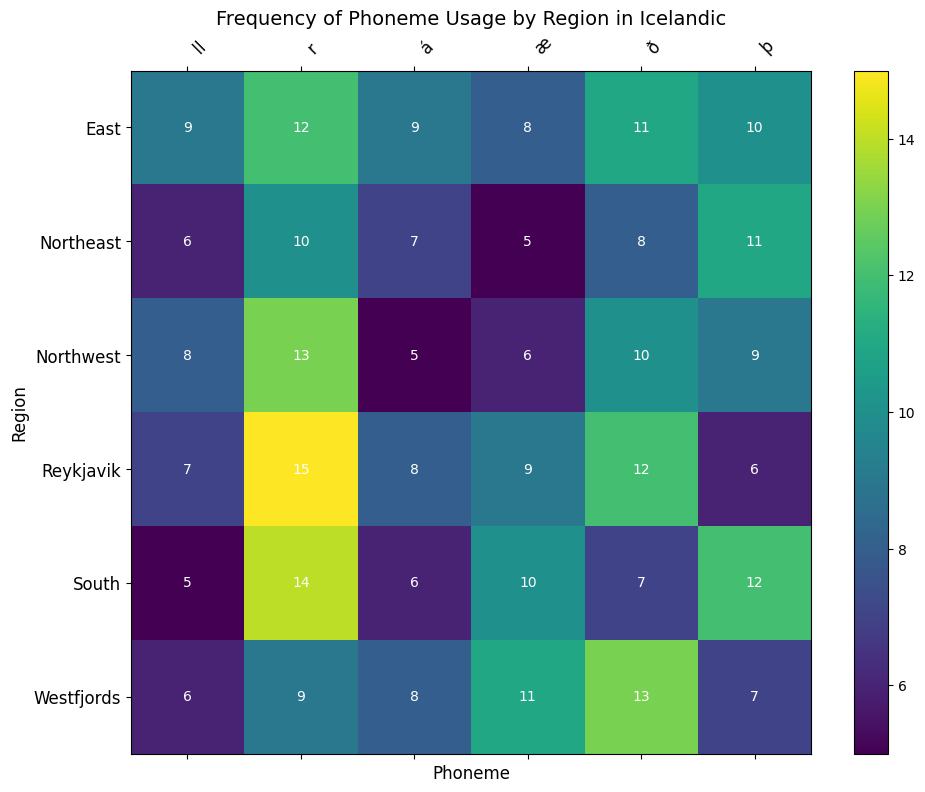Which region has the highest frequency of the phoneme "ð"? Look at the row labeled for each region and find the column for the phoneme "ð". Observe which cell has the highest value.
Answer: Westfjords What is the sum of the frequencies for the phoneme "á" across all regions? Add the values from the column for the phoneme "á" for all regions: 8 + 5 + 7 + 9 + 6 + 8. The sum is 8 + 5 + 7 + 9 + 6 + 8 = 43.
Answer: 43 Which region has the lowest frequency of the phoneme "ll"? Look at the row labeled for each region and find the column for the phoneme "ll". Observe which cell has the lowest value.
Answer: South How does the frequency of the phoneme "þ" in the South compare with that in the East? Look at the rows labeled "South" and "East" and find the values in the column labeled "þ". Compare the two values.
Answer: The frequency in the South is higher (12) than in the East (10) What is the average frequency of the phoneme "æ" across all regions? Add the values from the column for the phoneme "æ" for all regions: 9 + 6 + 5 + 8 + 10 + 11. Then divide this sum by the number of regions (6). The sum is 49, so the average is 49/6 ≈ 8.17.
Answer: 8.17 Which phoneme has the highest overall frequency when summing across all regions? Sum the frequencies for each phoneme across all regions: á: 8+5+7+9+6+8, ð: 12+10+8+11+7+13, þ: 6+9+11+10+12+7, æ: 9+6+5+8+10+11, r: 15+13+10+12+14+9, ll: 7+8+6+9+5+6. Then compare the sums.
Answer: r Which region uses the phoneme "r" the least frequently? Look at the row labeled for each region and find the column for the phoneme "r". Observe which cell has the lowest value.
Answer: Northeast What is the difference in frequency of the phoneme "þ" between Northwest and Northeast regions? Subtract the value for Northwest from the value for Northeast in the column for the phoneme "þ": 11 - 9 = 2.
Answer: 2 Is the phoneme "æ" used more frequently in Reykjavik or the Westfjords? Compare the values in the column for the phoneme "æ" for Reykjavik and Westfjords.
Answer: Westfjords 